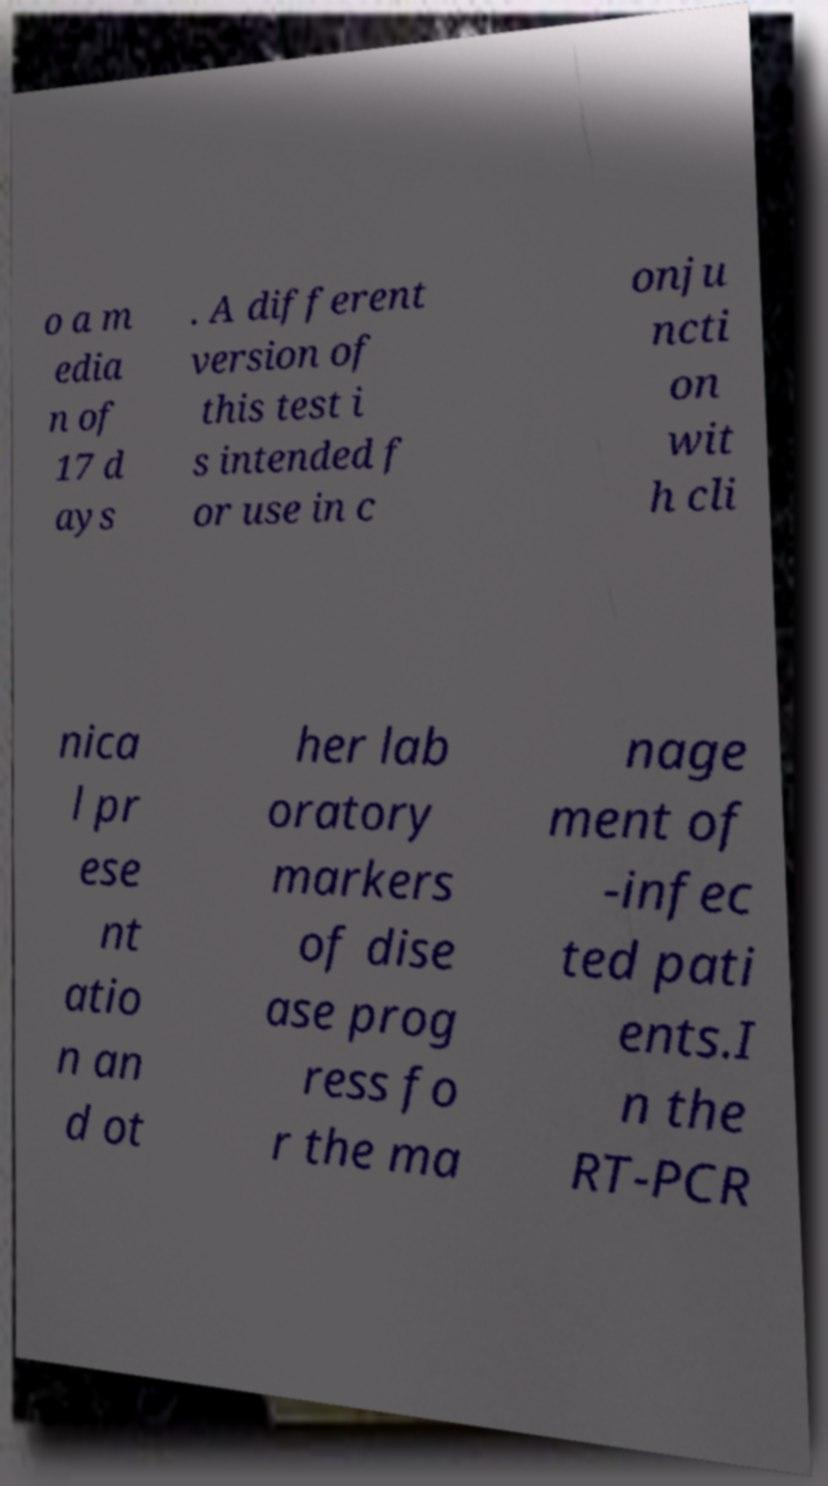Can you read and provide the text displayed in the image?This photo seems to have some interesting text. Can you extract and type it out for me? o a m edia n of 17 d ays . A different version of this test i s intended f or use in c onju ncti on wit h cli nica l pr ese nt atio n an d ot her lab oratory markers of dise ase prog ress fo r the ma nage ment of -infec ted pati ents.I n the RT-PCR 